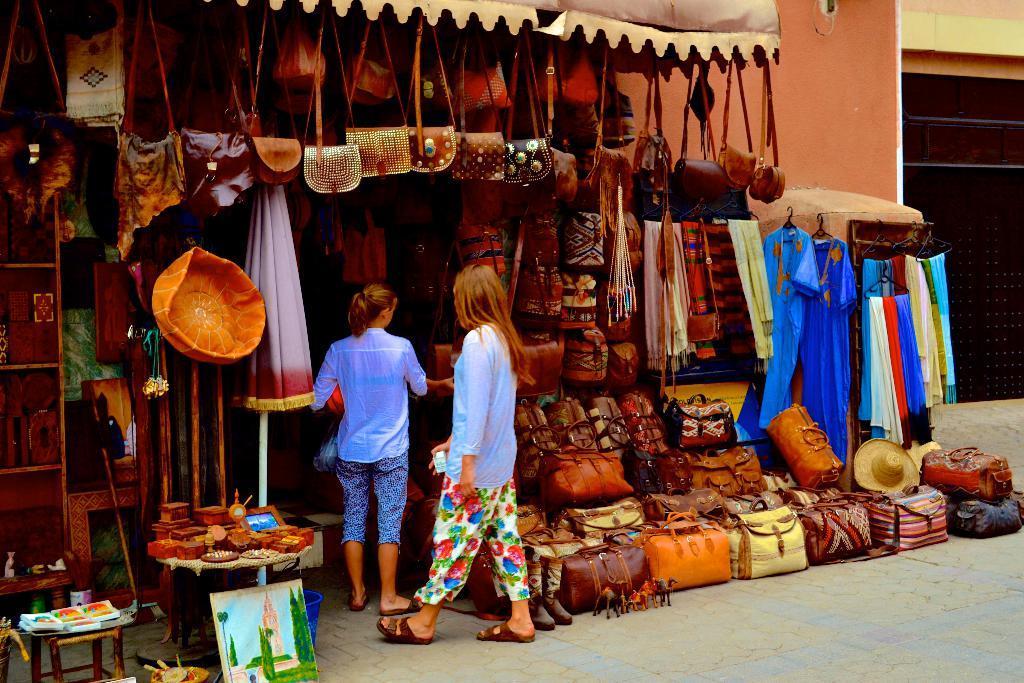Could you give a brief overview of what you see in this image? In this image there are two women standing on the ground. In front of them there is a stall. There are luggage bags, handbags, scarves, dresses, hats, sculptures and paintings in the stall. To the right there is a wall. 